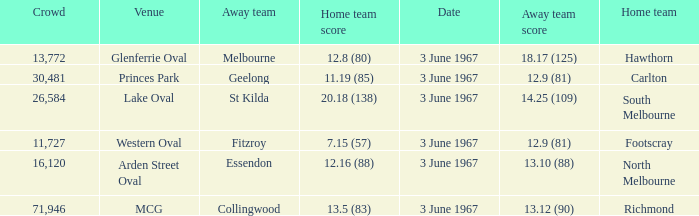Who was South Melbourne's away opponents? St Kilda. 